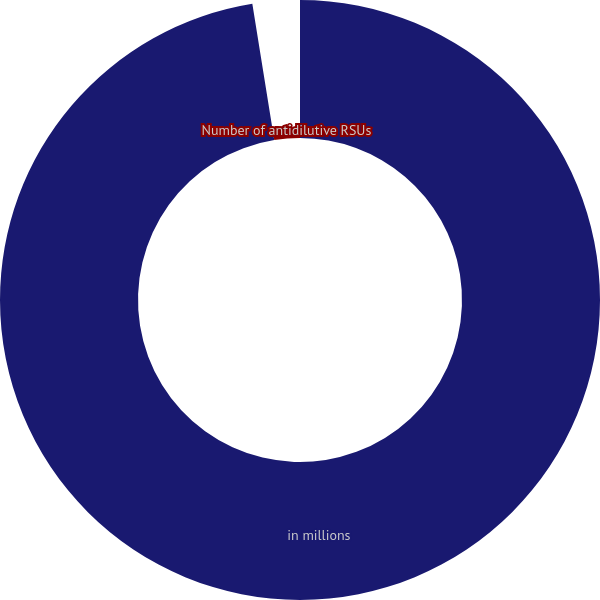Convert chart. <chart><loc_0><loc_0><loc_500><loc_500><pie_chart><fcel>in millions<fcel>Number of antidilutive RSUs<nl><fcel>97.46%<fcel>2.54%<nl></chart> 